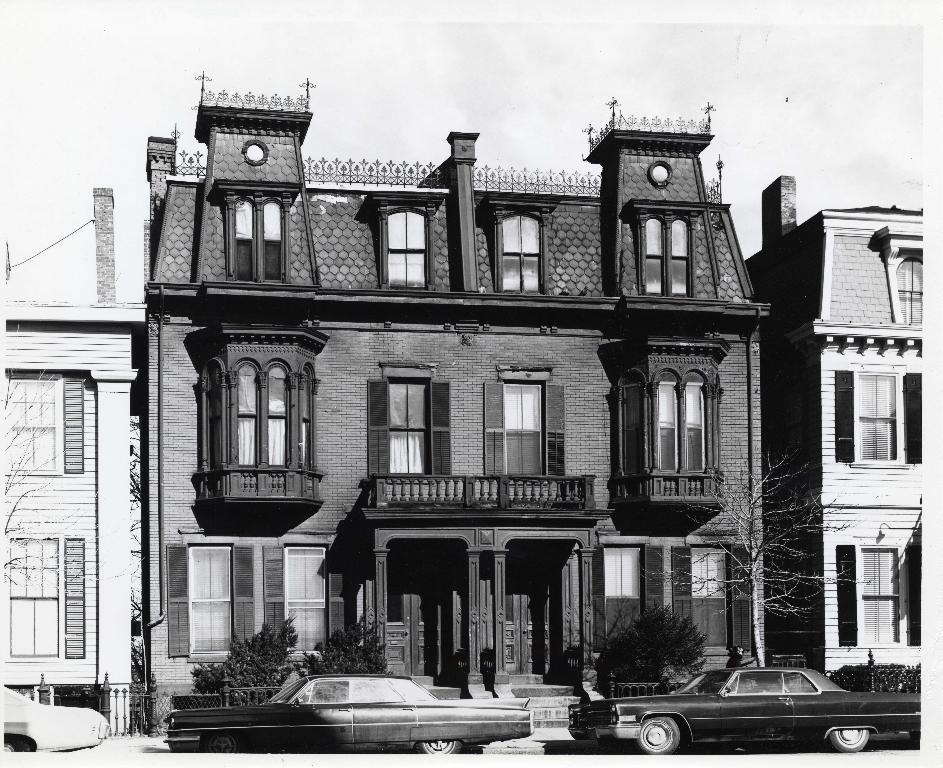How would you summarize this image in a sentence or two? This image consists of buildings and cars. There are doors and windows to the building. Beside the car, there are plants. At the top, there is a sky. 